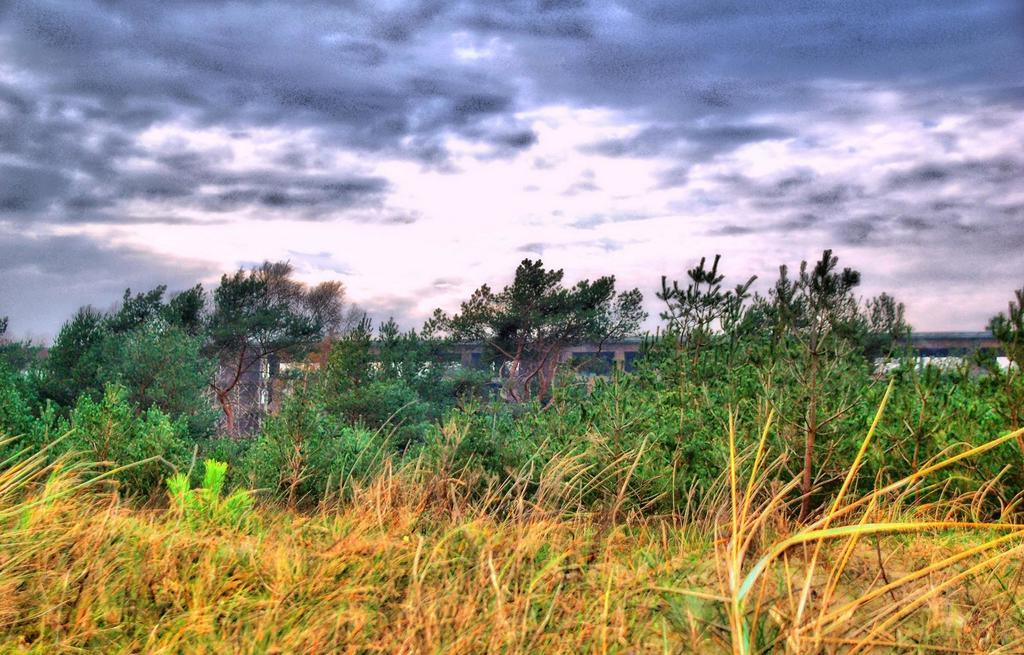What type of living organisms can be seen in the image? Plants can be seen in the image. What structure is visible in the background of the image? There is a bridge in the background of the image. What part of the natural environment is visible in the image? The sky is visible in the background of the image. How many quarters are visible on the ground in the image? There are no quarters present in the image; it features plants and a bridge in the background. 